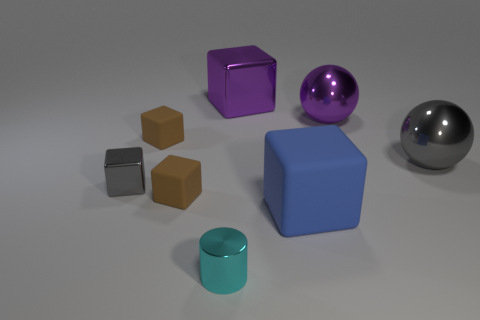Subtract all yellow spheres. How many brown blocks are left? 2 Subtract all gray blocks. How many blocks are left? 4 Subtract all small brown blocks. How many blocks are left? 3 Add 1 gray metal objects. How many objects exist? 9 Subtract all blocks. How many objects are left? 3 Subtract all cyan blocks. Subtract all purple balls. How many blocks are left? 5 Subtract all matte blocks. Subtract all small matte blocks. How many objects are left? 3 Add 5 metallic cubes. How many metallic cubes are left? 7 Add 1 large gray balls. How many large gray balls exist? 2 Subtract 0 red cylinders. How many objects are left? 8 